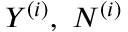<formula> <loc_0><loc_0><loc_500><loc_500>Y ^ { ( i ) } , N ^ { ( i ) }</formula> 